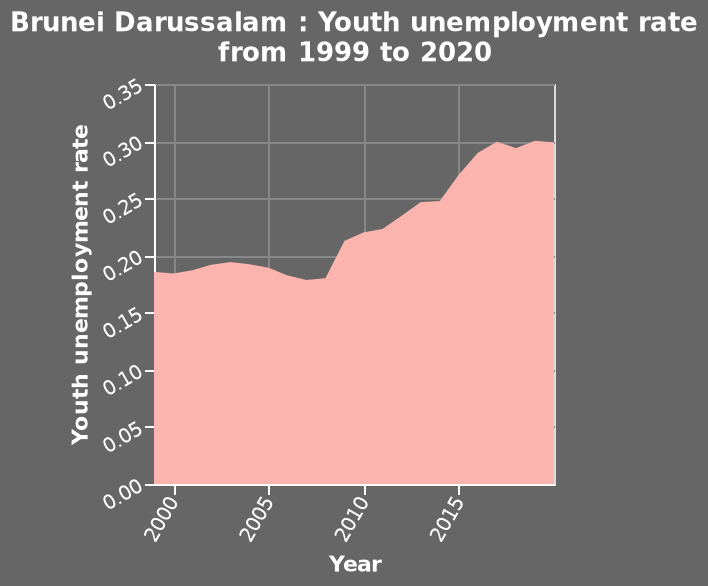<image>
What is the data represented by the area chart? The data represented by the area chart is the youth unemployment rate in Brunei Darussalam from 1999 to 2020. What was the youth unemployment rate in Darussalam between 1999 and 2009?  The youth unemployment rate in Darussalam between 1999 and 2009 remained fairly steady, staying between 0.16-0.19. Is the data represented by the area chart the adult employment rate in Brunei Darussalam from 1999 to 2020? No.The data represented by the area chart is the youth unemployment rate in Brunei Darussalam from 1999 to 2020. 